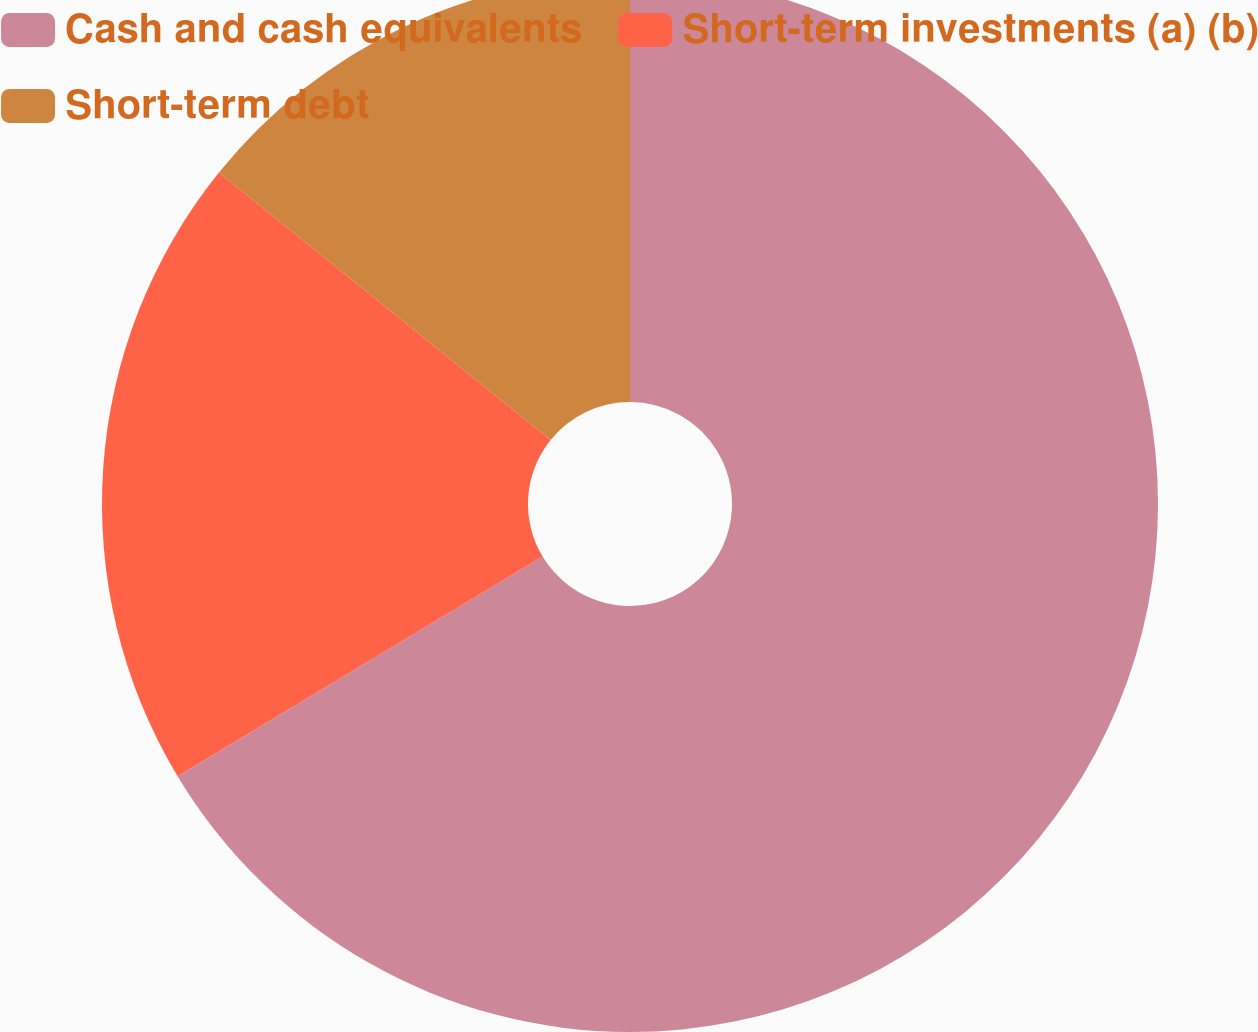Convert chart. <chart><loc_0><loc_0><loc_500><loc_500><pie_chart><fcel>Cash and cash equivalents<fcel>Short-term investments (a) (b)<fcel>Short-term debt<nl><fcel>66.38%<fcel>19.42%<fcel>14.2%<nl></chart> 